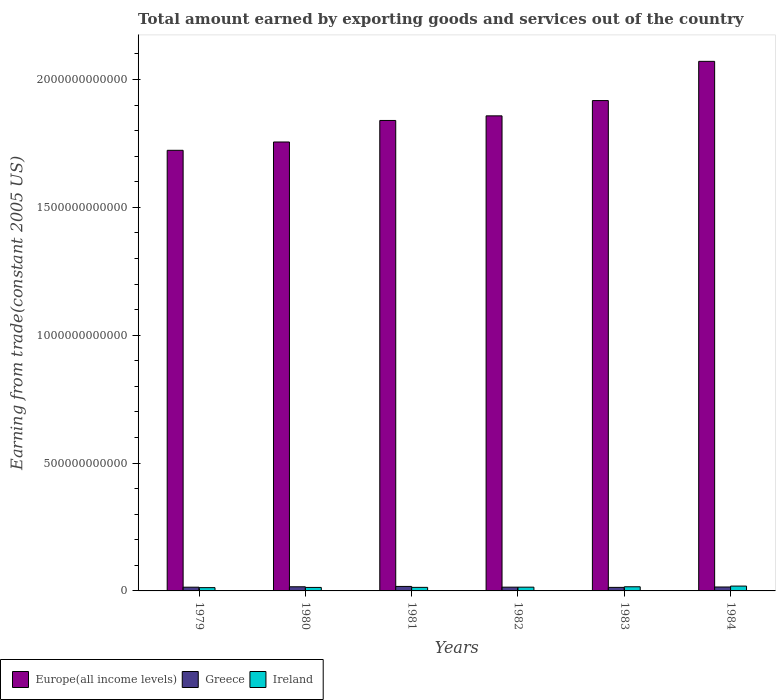How many different coloured bars are there?
Offer a terse response. 3. How many groups of bars are there?
Provide a short and direct response. 6. How many bars are there on the 3rd tick from the left?
Give a very brief answer. 3. What is the label of the 5th group of bars from the left?
Your answer should be compact. 1983. What is the total amount earned by exporting goods and services in Ireland in 1982?
Provide a succinct answer. 1.47e+1. Across all years, what is the maximum total amount earned by exporting goods and services in Ireland?
Make the answer very short. 1.89e+1. Across all years, what is the minimum total amount earned by exporting goods and services in Europe(all income levels)?
Your answer should be compact. 1.72e+12. In which year was the total amount earned by exporting goods and services in Greece maximum?
Your answer should be compact. 1981. What is the total total amount earned by exporting goods and services in Europe(all income levels) in the graph?
Your response must be concise. 1.12e+13. What is the difference between the total amount earned by exporting goods and services in Europe(all income levels) in 1979 and that in 1984?
Offer a very short reply. -3.48e+11. What is the difference between the total amount earned by exporting goods and services in Ireland in 1982 and the total amount earned by exporting goods and services in Greece in 1983?
Offer a very short reply. 8.61e+08. What is the average total amount earned by exporting goods and services in Greece per year?
Provide a succinct answer. 1.54e+1. In the year 1984, what is the difference between the total amount earned by exporting goods and services in Europe(all income levels) and total amount earned by exporting goods and services in Greece?
Your answer should be very brief. 2.06e+12. In how many years, is the total amount earned by exporting goods and services in Ireland greater than 700000000000 US$?
Make the answer very short. 0. What is the ratio of the total amount earned by exporting goods and services in Europe(all income levels) in 1980 to that in 1983?
Provide a succinct answer. 0.92. What is the difference between the highest and the second highest total amount earned by exporting goods and services in Ireland?
Give a very brief answer. 2.69e+09. What is the difference between the highest and the lowest total amount earned by exporting goods and services in Europe(all income levels)?
Offer a terse response. 3.48e+11. Is the sum of the total amount earned by exporting goods and services in Europe(all income levels) in 1979 and 1980 greater than the maximum total amount earned by exporting goods and services in Greece across all years?
Offer a very short reply. Yes. What does the 2nd bar from the left in 1982 represents?
Offer a very short reply. Greece. What does the 1st bar from the right in 1982 represents?
Offer a terse response. Ireland. What is the difference between two consecutive major ticks on the Y-axis?
Make the answer very short. 5.00e+11. Does the graph contain any zero values?
Give a very brief answer. No. What is the title of the graph?
Provide a succinct answer. Total amount earned by exporting goods and services out of the country. What is the label or title of the X-axis?
Your answer should be compact. Years. What is the label or title of the Y-axis?
Offer a terse response. Earning from trade(constant 2005 US). What is the Earning from trade(constant 2005 US) in Europe(all income levels) in 1979?
Offer a terse response. 1.72e+12. What is the Earning from trade(constant 2005 US) in Greece in 1979?
Your response must be concise. 1.46e+1. What is the Earning from trade(constant 2005 US) of Ireland in 1979?
Your answer should be very brief. 1.28e+1. What is the Earning from trade(constant 2005 US) of Europe(all income levels) in 1980?
Give a very brief answer. 1.76e+12. What is the Earning from trade(constant 2005 US) in Greece in 1980?
Provide a succinct answer. 1.62e+1. What is the Earning from trade(constant 2005 US) in Ireland in 1980?
Make the answer very short. 1.36e+1. What is the Earning from trade(constant 2005 US) of Europe(all income levels) in 1981?
Keep it short and to the point. 1.84e+12. What is the Earning from trade(constant 2005 US) of Greece in 1981?
Provide a short and direct response. 1.76e+1. What is the Earning from trade(constant 2005 US) in Ireland in 1981?
Offer a terse response. 1.39e+1. What is the Earning from trade(constant 2005 US) in Europe(all income levels) in 1982?
Offer a very short reply. 1.86e+12. What is the Earning from trade(constant 2005 US) of Greece in 1982?
Make the answer very short. 1.47e+1. What is the Earning from trade(constant 2005 US) of Ireland in 1982?
Provide a short and direct response. 1.47e+1. What is the Earning from trade(constant 2005 US) in Europe(all income levels) in 1983?
Your answer should be very brief. 1.92e+12. What is the Earning from trade(constant 2005 US) of Greece in 1983?
Make the answer very short. 1.38e+1. What is the Earning from trade(constant 2005 US) of Ireland in 1983?
Give a very brief answer. 1.62e+1. What is the Earning from trade(constant 2005 US) in Europe(all income levels) in 1984?
Provide a succinct answer. 2.07e+12. What is the Earning from trade(constant 2005 US) in Greece in 1984?
Ensure brevity in your answer.  1.53e+1. What is the Earning from trade(constant 2005 US) of Ireland in 1984?
Keep it short and to the point. 1.89e+1. Across all years, what is the maximum Earning from trade(constant 2005 US) of Europe(all income levels)?
Your answer should be compact. 2.07e+12. Across all years, what is the maximum Earning from trade(constant 2005 US) in Greece?
Make the answer very short. 1.76e+1. Across all years, what is the maximum Earning from trade(constant 2005 US) of Ireland?
Your answer should be very brief. 1.89e+1. Across all years, what is the minimum Earning from trade(constant 2005 US) of Europe(all income levels)?
Your answer should be very brief. 1.72e+12. Across all years, what is the minimum Earning from trade(constant 2005 US) in Greece?
Provide a short and direct response. 1.38e+1. Across all years, what is the minimum Earning from trade(constant 2005 US) in Ireland?
Ensure brevity in your answer.  1.28e+1. What is the total Earning from trade(constant 2005 US) in Europe(all income levels) in the graph?
Ensure brevity in your answer.  1.12e+13. What is the total Earning from trade(constant 2005 US) in Greece in the graph?
Provide a short and direct response. 9.22e+1. What is the total Earning from trade(constant 2005 US) of Ireland in the graph?
Ensure brevity in your answer.  9.02e+1. What is the difference between the Earning from trade(constant 2005 US) of Europe(all income levels) in 1979 and that in 1980?
Your answer should be very brief. -3.25e+1. What is the difference between the Earning from trade(constant 2005 US) of Greece in 1979 and that in 1980?
Provide a succinct answer. -1.62e+09. What is the difference between the Earning from trade(constant 2005 US) of Ireland in 1979 and that in 1980?
Your answer should be compact. -8.15e+08. What is the difference between the Earning from trade(constant 2005 US) of Europe(all income levels) in 1979 and that in 1981?
Your answer should be very brief. -1.17e+11. What is the difference between the Earning from trade(constant 2005 US) of Greece in 1979 and that in 1981?
Provide a short and direct response. -2.98e+09. What is the difference between the Earning from trade(constant 2005 US) of Ireland in 1979 and that in 1981?
Make the answer very short. -1.08e+09. What is the difference between the Earning from trade(constant 2005 US) of Europe(all income levels) in 1979 and that in 1982?
Make the answer very short. -1.35e+11. What is the difference between the Earning from trade(constant 2005 US) of Greece in 1979 and that in 1982?
Provide a succinct answer. -8.53e+07. What is the difference between the Earning from trade(constant 2005 US) in Ireland in 1979 and that in 1982?
Offer a very short reply. -1.85e+09. What is the difference between the Earning from trade(constant 2005 US) of Europe(all income levels) in 1979 and that in 1983?
Keep it short and to the point. -1.95e+11. What is the difference between the Earning from trade(constant 2005 US) in Greece in 1979 and that in 1983?
Offer a terse response. 7.73e+08. What is the difference between the Earning from trade(constant 2005 US) of Ireland in 1979 and that in 1983?
Give a very brief answer. -3.39e+09. What is the difference between the Earning from trade(constant 2005 US) in Europe(all income levels) in 1979 and that in 1984?
Give a very brief answer. -3.48e+11. What is the difference between the Earning from trade(constant 2005 US) in Greece in 1979 and that in 1984?
Your answer should be compact. -7.40e+08. What is the difference between the Earning from trade(constant 2005 US) of Ireland in 1979 and that in 1984?
Offer a terse response. -6.08e+09. What is the difference between the Earning from trade(constant 2005 US) of Europe(all income levels) in 1980 and that in 1981?
Offer a terse response. -8.42e+1. What is the difference between the Earning from trade(constant 2005 US) in Greece in 1980 and that in 1981?
Offer a terse response. -1.36e+09. What is the difference between the Earning from trade(constant 2005 US) in Ireland in 1980 and that in 1981?
Your answer should be compact. -2.67e+08. What is the difference between the Earning from trade(constant 2005 US) of Europe(all income levels) in 1980 and that in 1982?
Give a very brief answer. -1.02e+11. What is the difference between the Earning from trade(constant 2005 US) in Greece in 1980 and that in 1982?
Make the answer very short. 1.53e+09. What is the difference between the Earning from trade(constant 2005 US) of Ireland in 1980 and that in 1982?
Offer a very short reply. -1.04e+09. What is the difference between the Earning from trade(constant 2005 US) in Europe(all income levels) in 1980 and that in 1983?
Give a very brief answer. -1.62e+11. What is the difference between the Earning from trade(constant 2005 US) in Greece in 1980 and that in 1983?
Offer a very short reply. 2.39e+09. What is the difference between the Earning from trade(constant 2005 US) of Ireland in 1980 and that in 1983?
Keep it short and to the point. -2.57e+09. What is the difference between the Earning from trade(constant 2005 US) in Europe(all income levels) in 1980 and that in 1984?
Offer a very short reply. -3.15e+11. What is the difference between the Earning from trade(constant 2005 US) in Greece in 1980 and that in 1984?
Offer a terse response. 8.76e+08. What is the difference between the Earning from trade(constant 2005 US) of Ireland in 1980 and that in 1984?
Your answer should be very brief. -5.26e+09. What is the difference between the Earning from trade(constant 2005 US) of Europe(all income levels) in 1981 and that in 1982?
Your response must be concise. -1.81e+1. What is the difference between the Earning from trade(constant 2005 US) in Greece in 1981 and that in 1982?
Keep it short and to the point. 2.89e+09. What is the difference between the Earning from trade(constant 2005 US) of Ireland in 1981 and that in 1982?
Your answer should be compact. -7.70e+08. What is the difference between the Earning from trade(constant 2005 US) of Europe(all income levels) in 1981 and that in 1983?
Make the answer very short. -7.78e+1. What is the difference between the Earning from trade(constant 2005 US) of Greece in 1981 and that in 1983?
Make the answer very short. 3.75e+09. What is the difference between the Earning from trade(constant 2005 US) in Ireland in 1981 and that in 1983?
Your response must be concise. -2.31e+09. What is the difference between the Earning from trade(constant 2005 US) in Europe(all income levels) in 1981 and that in 1984?
Offer a terse response. -2.31e+11. What is the difference between the Earning from trade(constant 2005 US) in Greece in 1981 and that in 1984?
Keep it short and to the point. 2.24e+09. What is the difference between the Earning from trade(constant 2005 US) of Ireland in 1981 and that in 1984?
Keep it short and to the point. -5.00e+09. What is the difference between the Earning from trade(constant 2005 US) of Europe(all income levels) in 1982 and that in 1983?
Your response must be concise. -5.98e+1. What is the difference between the Earning from trade(constant 2005 US) in Greece in 1982 and that in 1983?
Give a very brief answer. 8.59e+08. What is the difference between the Earning from trade(constant 2005 US) in Ireland in 1982 and that in 1983?
Make the answer very short. -1.54e+09. What is the difference between the Earning from trade(constant 2005 US) of Europe(all income levels) in 1982 and that in 1984?
Offer a terse response. -2.13e+11. What is the difference between the Earning from trade(constant 2005 US) in Greece in 1982 and that in 1984?
Ensure brevity in your answer.  -6.55e+08. What is the difference between the Earning from trade(constant 2005 US) of Ireland in 1982 and that in 1984?
Provide a short and direct response. -4.23e+09. What is the difference between the Earning from trade(constant 2005 US) in Europe(all income levels) in 1983 and that in 1984?
Provide a short and direct response. -1.53e+11. What is the difference between the Earning from trade(constant 2005 US) in Greece in 1983 and that in 1984?
Offer a terse response. -1.51e+09. What is the difference between the Earning from trade(constant 2005 US) of Ireland in 1983 and that in 1984?
Provide a succinct answer. -2.69e+09. What is the difference between the Earning from trade(constant 2005 US) in Europe(all income levels) in 1979 and the Earning from trade(constant 2005 US) in Greece in 1980?
Keep it short and to the point. 1.71e+12. What is the difference between the Earning from trade(constant 2005 US) in Europe(all income levels) in 1979 and the Earning from trade(constant 2005 US) in Ireland in 1980?
Offer a very short reply. 1.71e+12. What is the difference between the Earning from trade(constant 2005 US) in Greece in 1979 and the Earning from trade(constant 2005 US) in Ireland in 1980?
Offer a very short reply. 9.49e+08. What is the difference between the Earning from trade(constant 2005 US) of Europe(all income levels) in 1979 and the Earning from trade(constant 2005 US) of Greece in 1981?
Provide a short and direct response. 1.71e+12. What is the difference between the Earning from trade(constant 2005 US) in Europe(all income levels) in 1979 and the Earning from trade(constant 2005 US) in Ireland in 1981?
Your answer should be compact. 1.71e+12. What is the difference between the Earning from trade(constant 2005 US) of Greece in 1979 and the Earning from trade(constant 2005 US) of Ireland in 1981?
Offer a terse response. 6.83e+08. What is the difference between the Earning from trade(constant 2005 US) of Europe(all income levels) in 1979 and the Earning from trade(constant 2005 US) of Greece in 1982?
Keep it short and to the point. 1.71e+12. What is the difference between the Earning from trade(constant 2005 US) in Europe(all income levels) in 1979 and the Earning from trade(constant 2005 US) in Ireland in 1982?
Make the answer very short. 1.71e+12. What is the difference between the Earning from trade(constant 2005 US) in Greece in 1979 and the Earning from trade(constant 2005 US) in Ireland in 1982?
Your answer should be very brief. -8.79e+07. What is the difference between the Earning from trade(constant 2005 US) of Europe(all income levels) in 1979 and the Earning from trade(constant 2005 US) of Greece in 1983?
Offer a terse response. 1.71e+12. What is the difference between the Earning from trade(constant 2005 US) in Europe(all income levels) in 1979 and the Earning from trade(constant 2005 US) in Ireland in 1983?
Provide a short and direct response. 1.71e+12. What is the difference between the Earning from trade(constant 2005 US) in Greece in 1979 and the Earning from trade(constant 2005 US) in Ireland in 1983?
Give a very brief answer. -1.62e+09. What is the difference between the Earning from trade(constant 2005 US) in Europe(all income levels) in 1979 and the Earning from trade(constant 2005 US) in Greece in 1984?
Offer a terse response. 1.71e+12. What is the difference between the Earning from trade(constant 2005 US) in Europe(all income levels) in 1979 and the Earning from trade(constant 2005 US) in Ireland in 1984?
Make the answer very short. 1.70e+12. What is the difference between the Earning from trade(constant 2005 US) in Greece in 1979 and the Earning from trade(constant 2005 US) in Ireland in 1984?
Your answer should be compact. -4.31e+09. What is the difference between the Earning from trade(constant 2005 US) in Europe(all income levels) in 1980 and the Earning from trade(constant 2005 US) in Greece in 1981?
Ensure brevity in your answer.  1.74e+12. What is the difference between the Earning from trade(constant 2005 US) of Europe(all income levels) in 1980 and the Earning from trade(constant 2005 US) of Ireland in 1981?
Your response must be concise. 1.74e+12. What is the difference between the Earning from trade(constant 2005 US) of Greece in 1980 and the Earning from trade(constant 2005 US) of Ireland in 1981?
Provide a short and direct response. 2.30e+09. What is the difference between the Earning from trade(constant 2005 US) of Europe(all income levels) in 1980 and the Earning from trade(constant 2005 US) of Greece in 1982?
Make the answer very short. 1.74e+12. What is the difference between the Earning from trade(constant 2005 US) of Europe(all income levels) in 1980 and the Earning from trade(constant 2005 US) of Ireland in 1982?
Your response must be concise. 1.74e+12. What is the difference between the Earning from trade(constant 2005 US) in Greece in 1980 and the Earning from trade(constant 2005 US) in Ireland in 1982?
Offer a terse response. 1.53e+09. What is the difference between the Earning from trade(constant 2005 US) of Europe(all income levels) in 1980 and the Earning from trade(constant 2005 US) of Greece in 1983?
Your response must be concise. 1.74e+12. What is the difference between the Earning from trade(constant 2005 US) in Europe(all income levels) in 1980 and the Earning from trade(constant 2005 US) in Ireland in 1983?
Your response must be concise. 1.74e+12. What is the difference between the Earning from trade(constant 2005 US) of Greece in 1980 and the Earning from trade(constant 2005 US) of Ireland in 1983?
Provide a short and direct response. -6.70e+06. What is the difference between the Earning from trade(constant 2005 US) of Europe(all income levels) in 1980 and the Earning from trade(constant 2005 US) of Greece in 1984?
Offer a terse response. 1.74e+12. What is the difference between the Earning from trade(constant 2005 US) of Europe(all income levels) in 1980 and the Earning from trade(constant 2005 US) of Ireland in 1984?
Your answer should be compact. 1.74e+12. What is the difference between the Earning from trade(constant 2005 US) in Greece in 1980 and the Earning from trade(constant 2005 US) in Ireland in 1984?
Provide a short and direct response. -2.70e+09. What is the difference between the Earning from trade(constant 2005 US) in Europe(all income levels) in 1981 and the Earning from trade(constant 2005 US) in Greece in 1982?
Your answer should be compact. 1.82e+12. What is the difference between the Earning from trade(constant 2005 US) in Europe(all income levels) in 1981 and the Earning from trade(constant 2005 US) in Ireland in 1982?
Your answer should be compact. 1.82e+12. What is the difference between the Earning from trade(constant 2005 US) in Greece in 1981 and the Earning from trade(constant 2005 US) in Ireland in 1982?
Make the answer very short. 2.89e+09. What is the difference between the Earning from trade(constant 2005 US) of Europe(all income levels) in 1981 and the Earning from trade(constant 2005 US) of Greece in 1983?
Give a very brief answer. 1.83e+12. What is the difference between the Earning from trade(constant 2005 US) of Europe(all income levels) in 1981 and the Earning from trade(constant 2005 US) of Ireland in 1983?
Your answer should be compact. 1.82e+12. What is the difference between the Earning from trade(constant 2005 US) in Greece in 1981 and the Earning from trade(constant 2005 US) in Ireland in 1983?
Provide a succinct answer. 1.36e+09. What is the difference between the Earning from trade(constant 2005 US) of Europe(all income levels) in 1981 and the Earning from trade(constant 2005 US) of Greece in 1984?
Make the answer very short. 1.82e+12. What is the difference between the Earning from trade(constant 2005 US) in Europe(all income levels) in 1981 and the Earning from trade(constant 2005 US) in Ireland in 1984?
Your answer should be compact. 1.82e+12. What is the difference between the Earning from trade(constant 2005 US) of Greece in 1981 and the Earning from trade(constant 2005 US) of Ireland in 1984?
Make the answer very short. -1.33e+09. What is the difference between the Earning from trade(constant 2005 US) in Europe(all income levels) in 1982 and the Earning from trade(constant 2005 US) in Greece in 1983?
Ensure brevity in your answer.  1.84e+12. What is the difference between the Earning from trade(constant 2005 US) in Europe(all income levels) in 1982 and the Earning from trade(constant 2005 US) in Ireland in 1983?
Provide a succinct answer. 1.84e+12. What is the difference between the Earning from trade(constant 2005 US) in Greece in 1982 and the Earning from trade(constant 2005 US) in Ireland in 1983?
Keep it short and to the point. -1.54e+09. What is the difference between the Earning from trade(constant 2005 US) in Europe(all income levels) in 1982 and the Earning from trade(constant 2005 US) in Greece in 1984?
Offer a terse response. 1.84e+12. What is the difference between the Earning from trade(constant 2005 US) in Europe(all income levels) in 1982 and the Earning from trade(constant 2005 US) in Ireland in 1984?
Give a very brief answer. 1.84e+12. What is the difference between the Earning from trade(constant 2005 US) in Greece in 1982 and the Earning from trade(constant 2005 US) in Ireland in 1984?
Your answer should be compact. -4.23e+09. What is the difference between the Earning from trade(constant 2005 US) of Europe(all income levels) in 1983 and the Earning from trade(constant 2005 US) of Greece in 1984?
Provide a succinct answer. 1.90e+12. What is the difference between the Earning from trade(constant 2005 US) in Europe(all income levels) in 1983 and the Earning from trade(constant 2005 US) in Ireland in 1984?
Give a very brief answer. 1.90e+12. What is the difference between the Earning from trade(constant 2005 US) of Greece in 1983 and the Earning from trade(constant 2005 US) of Ireland in 1984?
Offer a terse response. -5.09e+09. What is the average Earning from trade(constant 2005 US) in Europe(all income levels) per year?
Ensure brevity in your answer.  1.86e+12. What is the average Earning from trade(constant 2005 US) of Greece per year?
Your answer should be compact. 1.54e+1. What is the average Earning from trade(constant 2005 US) of Ireland per year?
Give a very brief answer. 1.50e+1. In the year 1979, what is the difference between the Earning from trade(constant 2005 US) in Europe(all income levels) and Earning from trade(constant 2005 US) in Greece?
Ensure brevity in your answer.  1.71e+12. In the year 1979, what is the difference between the Earning from trade(constant 2005 US) in Europe(all income levels) and Earning from trade(constant 2005 US) in Ireland?
Provide a short and direct response. 1.71e+12. In the year 1979, what is the difference between the Earning from trade(constant 2005 US) in Greece and Earning from trade(constant 2005 US) in Ireland?
Ensure brevity in your answer.  1.76e+09. In the year 1980, what is the difference between the Earning from trade(constant 2005 US) in Europe(all income levels) and Earning from trade(constant 2005 US) in Greece?
Your answer should be compact. 1.74e+12. In the year 1980, what is the difference between the Earning from trade(constant 2005 US) of Europe(all income levels) and Earning from trade(constant 2005 US) of Ireland?
Offer a very short reply. 1.74e+12. In the year 1980, what is the difference between the Earning from trade(constant 2005 US) of Greece and Earning from trade(constant 2005 US) of Ireland?
Give a very brief answer. 2.57e+09. In the year 1981, what is the difference between the Earning from trade(constant 2005 US) in Europe(all income levels) and Earning from trade(constant 2005 US) in Greece?
Provide a succinct answer. 1.82e+12. In the year 1981, what is the difference between the Earning from trade(constant 2005 US) in Europe(all income levels) and Earning from trade(constant 2005 US) in Ireland?
Keep it short and to the point. 1.83e+12. In the year 1981, what is the difference between the Earning from trade(constant 2005 US) in Greece and Earning from trade(constant 2005 US) in Ireland?
Your response must be concise. 3.66e+09. In the year 1982, what is the difference between the Earning from trade(constant 2005 US) in Europe(all income levels) and Earning from trade(constant 2005 US) in Greece?
Offer a very short reply. 1.84e+12. In the year 1982, what is the difference between the Earning from trade(constant 2005 US) in Europe(all income levels) and Earning from trade(constant 2005 US) in Ireland?
Ensure brevity in your answer.  1.84e+12. In the year 1982, what is the difference between the Earning from trade(constant 2005 US) of Greece and Earning from trade(constant 2005 US) of Ireland?
Provide a succinct answer. -2.50e+06. In the year 1983, what is the difference between the Earning from trade(constant 2005 US) of Europe(all income levels) and Earning from trade(constant 2005 US) of Greece?
Make the answer very short. 1.90e+12. In the year 1983, what is the difference between the Earning from trade(constant 2005 US) of Europe(all income levels) and Earning from trade(constant 2005 US) of Ireland?
Keep it short and to the point. 1.90e+12. In the year 1983, what is the difference between the Earning from trade(constant 2005 US) of Greece and Earning from trade(constant 2005 US) of Ireland?
Ensure brevity in your answer.  -2.40e+09. In the year 1984, what is the difference between the Earning from trade(constant 2005 US) in Europe(all income levels) and Earning from trade(constant 2005 US) in Greece?
Provide a short and direct response. 2.06e+12. In the year 1984, what is the difference between the Earning from trade(constant 2005 US) in Europe(all income levels) and Earning from trade(constant 2005 US) in Ireland?
Keep it short and to the point. 2.05e+12. In the year 1984, what is the difference between the Earning from trade(constant 2005 US) in Greece and Earning from trade(constant 2005 US) in Ireland?
Keep it short and to the point. -3.57e+09. What is the ratio of the Earning from trade(constant 2005 US) of Europe(all income levels) in 1979 to that in 1980?
Provide a short and direct response. 0.98. What is the ratio of the Earning from trade(constant 2005 US) of Greece in 1979 to that in 1980?
Make the answer very short. 0.9. What is the ratio of the Earning from trade(constant 2005 US) of Ireland in 1979 to that in 1980?
Ensure brevity in your answer.  0.94. What is the ratio of the Earning from trade(constant 2005 US) of Europe(all income levels) in 1979 to that in 1981?
Make the answer very short. 0.94. What is the ratio of the Earning from trade(constant 2005 US) of Greece in 1979 to that in 1981?
Ensure brevity in your answer.  0.83. What is the ratio of the Earning from trade(constant 2005 US) of Ireland in 1979 to that in 1981?
Ensure brevity in your answer.  0.92. What is the ratio of the Earning from trade(constant 2005 US) in Europe(all income levels) in 1979 to that in 1982?
Provide a short and direct response. 0.93. What is the ratio of the Earning from trade(constant 2005 US) of Greece in 1979 to that in 1982?
Your response must be concise. 0.99. What is the ratio of the Earning from trade(constant 2005 US) in Ireland in 1979 to that in 1982?
Make the answer very short. 0.87. What is the ratio of the Earning from trade(constant 2005 US) in Europe(all income levels) in 1979 to that in 1983?
Make the answer very short. 0.9. What is the ratio of the Earning from trade(constant 2005 US) in Greece in 1979 to that in 1983?
Your answer should be compact. 1.06. What is the ratio of the Earning from trade(constant 2005 US) in Ireland in 1979 to that in 1983?
Give a very brief answer. 0.79. What is the ratio of the Earning from trade(constant 2005 US) of Europe(all income levels) in 1979 to that in 1984?
Provide a short and direct response. 0.83. What is the ratio of the Earning from trade(constant 2005 US) of Greece in 1979 to that in 1984?
Your response must be concise. 0.95. What is the ratio of the Earning from trade(constant 2005 US) in Ireland in 1979 to that in 1984?
Your answer should be compact. 0.68. What is the ratio of the Earning from trade(constant 2005 US) of Europe(all income levels) in 1980 to that in 1981?
Make the answer very short. 0.95. What is the ratio of the Earning from trade(constant 2005 US) of Greece in 1980 to that in 1981?
Offer a very short reply. 0.92. What is the ratio of the Earning from trade(constant 2005 US) of Ireland in 1980 to that in 1981?
Give a very brief answer. 0.98. What is the ratio of the Earning from trade(constant 2005 US) in Europe(all income levels) in 1980 to that in 1982?
Provide a succinct answer. 0.94. What is the ratio of the Earning from trade(constant 2005 US) in Greece in 1980 to that in 1982?
Make the answer very short. 1.1. What is the ratio of the Earning from trade(constant 2005 US) in Ireland in 1980 to that in 1982?
Offer a terse response. 0.93. What is the ratio of the Earning from trade(constant 2005 US) of Europe(all income levels) in 1980 to that in 1983?
Your answer should be compact. 0.92. What is the ratio of the Earning from trade(constant 2005 US) of Greece in 1980 to that in 1983?
Offer a terse response. 1.17. What is the ratio of the Earning from trade(constant 2005 US) of Ireland in 1980 to that in 1983?
Make the answer very short. 0.84. What is the ratio of the Earning from trade(constant 2005 US) of Europe(all income levels) in 1980 to that in 1984?
Your answer should be very brief. 0.85. What is the ratio of the Earning from trade(constant 2005 US) of Greece in 1980 to that in 1984?
Ensure brevity in your answer.  1.06. What is the ratio of the Earning from trade(constant 2005 US) in Ireland in 1980 to that in 1984?
Your answer should be very brief. 0.72. What is the ratio of the Earning from trade(constant 2005 US) of Europe(all income levels) in 1981 to that in 1982?
Offer a very short reply. 0.99. What is the ratio of the Earning from trade(constant 2005 US) in Greece in 1981 to that in 1982?
Give a very brief answer. 1.2. What is the ratio of the Earning from trade(constant 2005 US) in Ireland in 1981 to that in 1982?
Provide a short and direct response. 0.95. What is the ratio of the Earning from trade(constant 2005 US) in Europe(all income levels) in 1981 to that in 1983?
Give a very brief answer. 0.96. What is the ratio of the Earning from trade(constant 2005 US) of Greece in 1981 to that in 1983?
Your answer should be very brief. 1.27. What is the ratio of the Earning from trade(constant 2005 US) in Ireland in 1981 to that in 1983?
Your answer should be compact. 0.86. What is the ratio of the Earning from trade(constant 2005 US) of Europe(all income levels) in 1981 to that in 1984?
Offer a very short reply. 0.89. What is the ratio of the Earning from trade(constant 2005 US) of Greece in 1981 to that in 1984?
Provide a short and direct response. 1.15. What is the ratio of the Earning from trade(constant 2005 US) of Ireland in 1981 to that in 1984?
Make the answer very short. 0.74. What is the ratio of the Earning from trade(constant 2005 US) of Europe(all income levels) in 1982 to that in 1983?
Your response must be concise. 0.97. What is the ratio of the Earning from trade(constant 2005 US) in Greece in 1982 to that in 1983?
Give a very brief answer. 1.06. What is the ratio of the Earning from trade(constant 2005 US) in Ireland in 1982 to that in 1983?
Provide a succinct answer. 0.91. What is the ratio of the Earning from trade(constant 2005 US) in Europe(all income levels) in 1982 to that in 1984?
Offer a terse response. 0.9. What is the ratio of the Earning from trade(constant 2005 US) of Greece in 1982 to that in 1984?
Ensure brevity in your answer.  0.96. What is the ratio of the Earning from trade(constant 2005 US) in Ireland in 1982 to that in 1984?
Ensure brevity in your answer.  0.78. What is the ratio of the Earning from trade(constant 2005 US) in Europe(all income levels) in 1983 to that in 1984?
Offer a very short reply. 0.93. What is the ratio of the Earning from trade(constant 2005 US) of Greece in 1983 to that in 1984?
Offer a very short reply. 0.9. What is the ratio of the Earning from trade(constant 2005 US) in Ireland in 1983 to that in 1984?
Keep it short and to the point. 0.86. What is the difference between the highest and the second highest Earning from trade(constant 2005 US) in Europe(all income levels)?
Your answer should be very brief. 1.53e+11. What is the difference between the highest and the second highest Earning from trade(constant 2005 US) of Greece?
Give a very brief answer. 1.36e+09. What is the difference between the highest and the second highest Earning from trade(constant 2005 US) of Ireland?
Your answer should be very brief. 2.69e+09. What is the difference between the highest and the lowest Earning from trade(constant 2005 US) in Europe(all income levels)?
Your answer should be very brief. 3.48e+11. What is the difference between the highest and the lowest Earning from trade(constant 2005 US) in Greece?
Give a very brief answer. 3.75e+09. What is the difference between the highest and the lowest Earning from trade(constant 2005 US) of Ireland?
Your answer should be very brief. 6.08e+09. 